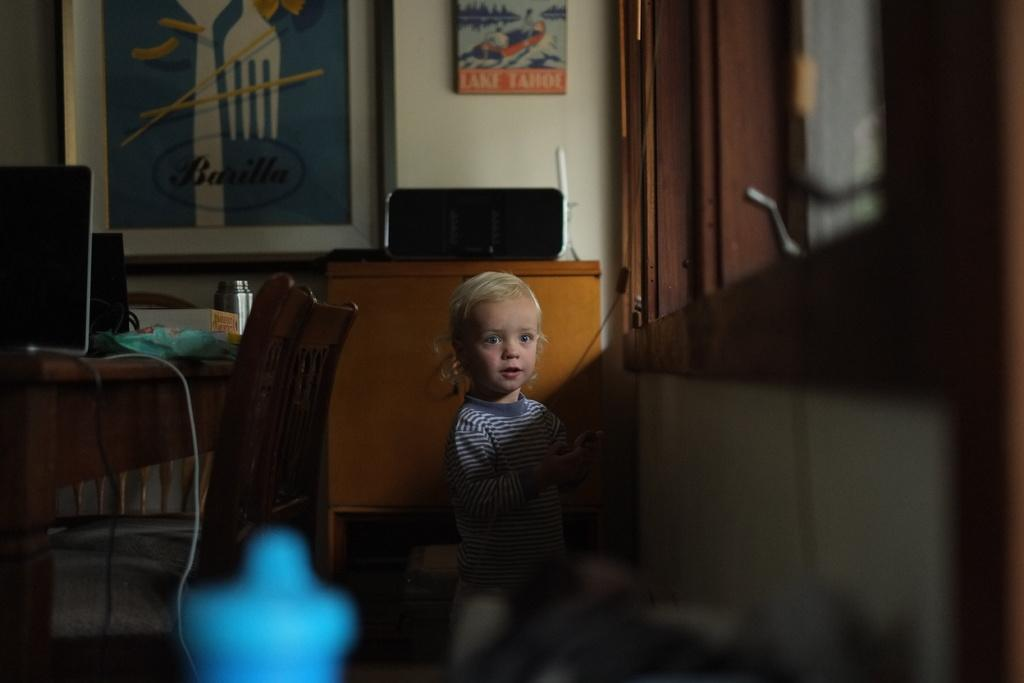What is the main subject of the image? There is a girl standing in the image. What can be seen in the background of the image? There is a wall, a photo frame, a door, a table with objects, and chairs in the background of the image. What type of pan is being used by the girl to catch the clam in the image? There is no pan or clam present in the image; it features a girl standing in front of a background with various objects and structures. 